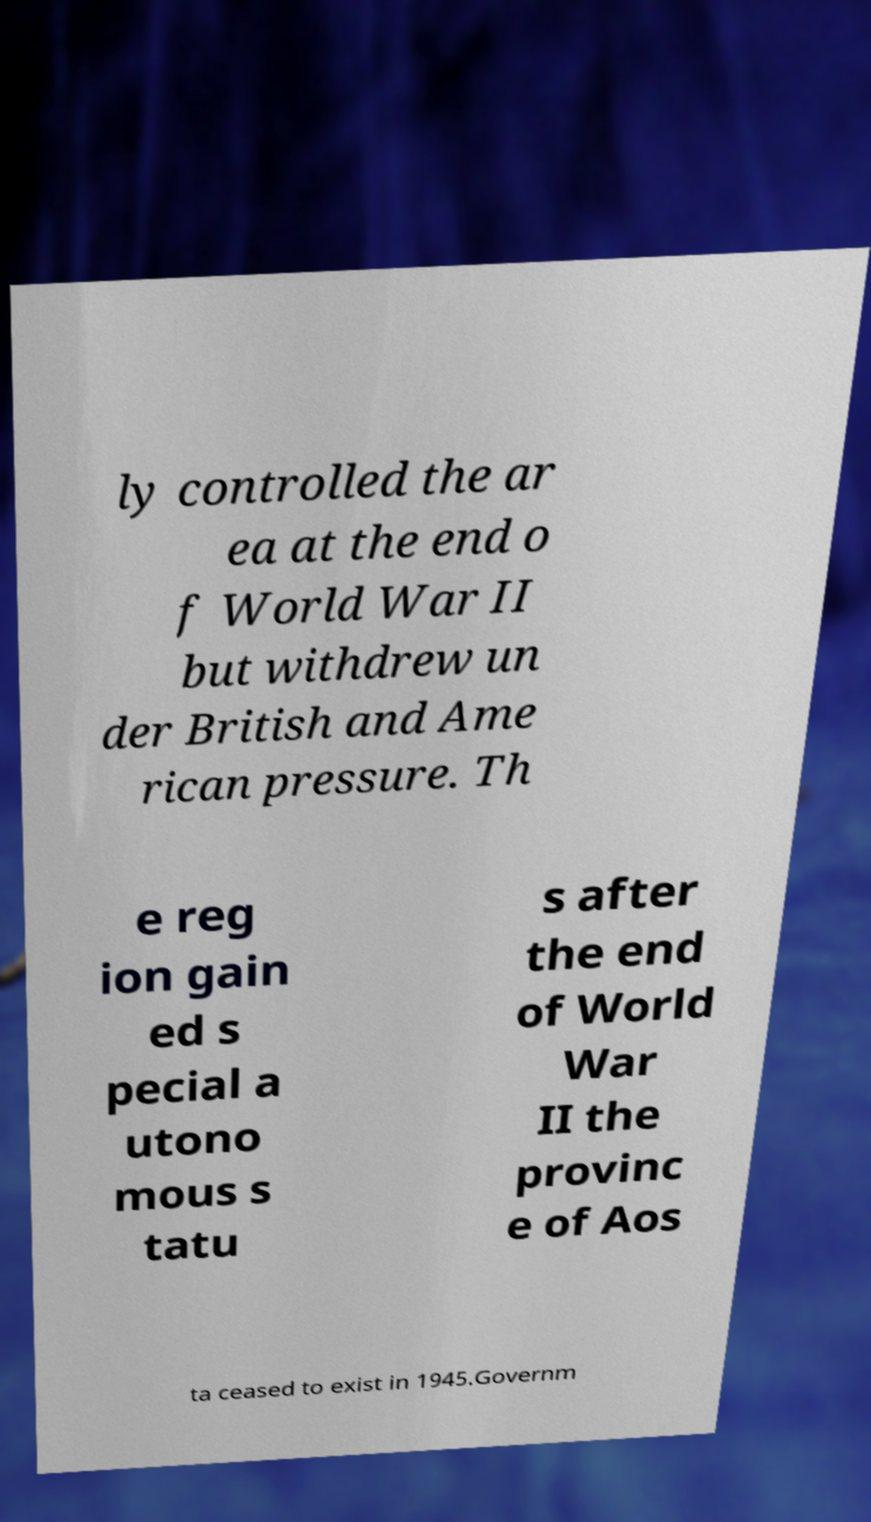Can you read and provide the text displayed in the image?This photo seems to have some interesting text. Can you extract and type it out for me? ly controlled the ar ea at the end o f World War II but withdrew un der British and Ame rican pressure. Th e reg ion gain ed s pecial a utono mous s tatu s after the end of World War II the provinc e of Aos ta ceased to exist in 1945.Governm 